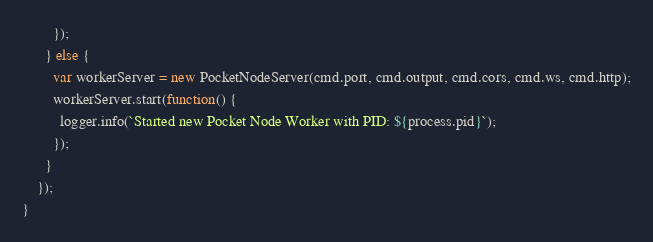Convert code to text. <code><loc_0><loc_0><loc_500><loc_500><_JavaScript_>        });
      } else {
        var workerServer = new PocketNodeServer(cmd.port, cmd.output, cmd.cors, cmd.ws, cmd.http);
        workerServer.start(function() {
          logger.info(`Started new Pocket Node Worker with PID: ${process.pid}`);
        });
      }
    });
}
</code> 